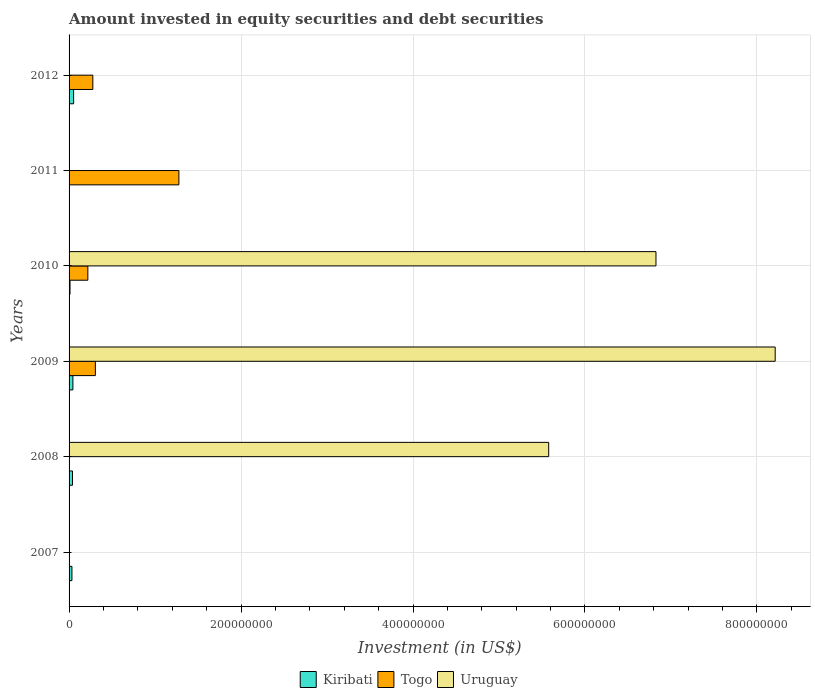Are the number of bars on each tick of the Y-axis equal?
Offer a terse response. No. How many bars are there on the 1st tick from the top?
Give a very brief answer. 2. How many bars are there on the 2nd tick from the bottom?
Keep it short and to the point. 2. What is the label of the 1st group of bars from the top?
Provide a short and direct response. 2012. In how many cases, is the number of bars for a given year not equal to the number of legend labels?
Ensure brevity in your answer.  4. What is the amount invested in equity securities and debt securities in Kiribati in 2011?
Your response must be concise. 0. Across all years, what is the maximum amount invested in equity securities and debt securities in Kiribati?
Offer a very short reply. 5.30e+06. What is the total amount invested in equity securities and debt securities in Togo in the graph?
Your response must be concise. 2.08e+08. What is the difference between the amount invested in equity securities and debt securities in Kiribati in 2008 and that in 2010?
Keep it short and to the point. 2.87e+06. What is the difference between the amount invested in equity securities and debt securities in Kiribati in 2011 and the amount invested in equity securities and debt securities in Uruguay in 2007?
Ensure brevity in your answer.  0. What is the average amount invested in equity securities and debt securities in Togo per year?
Provide a succinct answer. 3.46e+07. In the year 2009, what is the difference between the amount invested in equity securities and debt securities in Uruguay and amount invested in equity securities and debt securities in Kiribati?
Keep it short and to the point. 8.17e+08. In how many years, is the amount invested in equity securities and debt securities in Togo greater than 760000000 US$?
Offer a very short reply. 0. What is the ratio of the amount invested in equity securities and debt securities in Togo in 2009 to that in 2011?
Offer a very short reply. 0.24. What is the difference between the highest and the second highest amount invested in equity securities and debt securities in Kiribati?
Offer a terse response. 8.62e+05. What is the difference between the highest and the lowest amount invested in equity securities and debt securities in Uruguay?
Offer a very short reply. 8.21e+08. In how many years, is the amount invested in equity securities and debt securities in Togo greater than the average amount invested in equity securities and debt securities in Togo taken over all years?
Provide a short and direct response. 1. Is the sum of the amount invested in equity securities and debt securities in Kiribati in 2008 and 2010 greater than the maximum amount invested in equity securities and debt securities in Togo across all years?
Make the answer very short. No. Does the graph contain any zero values?
Provide a short and direct response. Yes. Does the graph contain grids?
Your answer should be compact. Yes. Where does the legend appear in the graph?
Your response must be concise. Bottom center. How many legend labels are there?
Provide a succinct answer. 3. What is the title of the graph?
Your response must be concise. Amount invested in equity securities and debt securities. Does "Somalia" appear as one of the legend labels in the graph?
Your response must be concise. No. What is the label or title of the X-axis?
Give a very brief answer. Investment (in US$). What is the Investment (in US$) of Kiribati in 2007?
Offer a very short reply. 3.34e+06. What is the Investment (in US$) of Togo in 2007?
Your response must be concise. 0. What is the Investment (in US$) of Uruguay in 2007?
Offer a very short reply. 0. What is the Investment (in US$) in Kiribati in 2008?
Your response must be concise. 3.97e+06. What is the Investment (in US$) in Togo in 2008?
Your answer should be compact. 0. What is the Investment (in US$) of Uruguay in 2008?
Provide a succinct answer. 5.58e+08. What is the Investment (in US$) of Kiribati in 2009?
Offer a very short reply. 4.43e+06. What is the Investment (in US$) of Togo in 2009?
Your response must be concise. 3.06e+07. What is the Investment (in US$) in Uruguay in 2009?
Ensure brevity in your answer.  8.21e+08. What is the Investment (in US$) in Kiribati in 2010?
Give a very brief answer. 1.10e+06. What is the Investment (in US$) of Togo in 2010?
Your response must be concise. 2.18e+07. What is the Investment (in US$) of Uruguay in 2010?
Ensure brevity in your answer.  6.83e+08. What is the Investment (in US$) in Togo in 2011?
Your response must be concise. 1.28e+08. What is the Investment (in US$) in Kiribati in 2012?
Your response must be concise. 5.30e+06. What is the Investment (in US$) in Togo in 2012?
Provide a short and direct response. 2.76e+07. Across all years, what is the maximum Investment (in US$) of Kiribati?
Give a very brief answer. 5.30e+06. Across all years, what is the maximum Investment (in US$) of Togo?
Provide a short and direct response. 1.28e+08. Across all years, what is the maximum Investment (in US$) in Uruguay?
Offer a terse response. 8.21e+08. Across all years, what is the minimum Investment (in US$) of Togo?
Make the answer very short. 0. Across all years, what is the minimum Investment (in US$) of Uruguay?
Offer a very short reply. 0. What is the total Investment (in US$) of Kiribati in the graph?
Keep it short and to the point. 1.81e+07. What is the total Investment (in US$) in Togo in the graph?
Your response must be concise. 2.08e+08. What is the total Investment (in US$) of Uruguay in the graph?
Offer a very short reply. 2.06e+09. What is the difference between the Investment (in US$) of Kiribati in 2007 and that in 2008?
Offer a terse response. -6.28e+05. What is the difference between the Investment (in US$) in Kiribati in 2007 and that in 2009?
Provide a succinct answer. -1.09e+06. What is the difference between the Investment (in US$) of Kiribati in 2007 and that in 2010?
Your response must be concise. 2.24e+06. What is the difference between the Investment (in US$) of Kiribati in 2007 and that in 2012?
Your answer should be very brief. -1.96e+06. What is the difference between the Investment (in US$) of Kiribati in 2008 and that in 2009?
Your answer should be compact. -4.67e+05. What is the difference between the Investment (in US$) of Uruguay in 2008 and that in 2009?
Ensure brevity in your answer.  -2.63e+08. What is the difference between the Investment (in US$) in Kiribati in 2008 and that in 2010?
Make the answer very short. 2.87e+06. What is the difference between the Investment (in US$) of Uruguay in 2008 and that in 2010?
Give a very brief answer. -1.25e+08. What is the difference between the Investment (in US$) in Kiribati in 2008 and that in 2012?
Ensure brevity in your answer.  -1.33e+06. What is the difference between the Investment (in US$) in Kiribati in 2009 and that in 2010?
Give a very brief answer. 3.34e+06. What is the difference between the Investment (in US$) in Togo in 2009 and that in 2010?
Keep it short and to the point. 8.74e+06. What is the difference between the Investment (in US$) of Uruguay in 2009 and that in 2010?
Offer a terse response. 1.39e+08. What is the difference between the Investment (in US$) in Togo in 2009 and that in 2011?
Your response must be concise. -9.71e+07. What is the difference between the Investment (in US$) in Kiribati in 2009 and that in 2012?
Ensure brevity in your answer.  -8.62e+05. What is the difference between the Investment (in US$) of Togo in 2009 and that in 2012?
Give a very brief answer. 2.93e+06. What is the difference between the Investment (in US$) in Togo in 2010 and that in 2011?
Make the answer very short. -1.06e+08. What is the difference between the Investment (in US$) in Kiribati in 2010 and that in 2012?
Provide a short and direct response. -4.20e+06. What is the difference between the Investment (in US$) of Togo in 2010 and that in 2012?
Offer a terse response. -5.81e+06. What is the difference between the Investment (in US$) in Togo in 2011 and that in 2012?
Your answer should be compact. 1.00e+08. What is the difference between the Investment (in US$) in Kiribati in 2007 and the Investment (in US$) in Uruguay in 2008?
Make the answer very short. -5.54e+08. What is the difference between the Investment (in US$) of Kiribati in 2007 and the Investment (in US$) of Togo in 2009?
Your response must be concise. -2.72e+07. What is the difference between the Investment (in US$) of Kiribati in 2007 and the Investment (in US$) of Uruguay in 2009?
Ensure brevity in your answer.  -8.18e+08. What is the difference between the Investment (in US$) of Kiribati in 2007 and the Investment (in US$) of Togo in 2010?
Provide a succinct answer. -1.85e+07. What is the difference between the Investment (in US$) in Kiribati in 2007 and the Investment (in US$) in Uruguay in 2010?
Make the answer very short. -6.79e+08. What is the difference between the Investment (in US$) in Kiribati in 2007 and the Investment (in US$) in Togo in 2011?
Offer a very short reply. -1.24e+08. What is the difference between the Investment (in US$) of Kiribati in 2007 and the Investment (in US$) of Togo in 2012?
Your answer should be compact. -2.43e+07. What is the difference between the Investment (in US$) in Kiribati in 2008 and the Investment (in US$) in Togo in 2009?
Give a very brief answer. -2.66e+07. What is the difference between the Investment (in US$) in Kiribati in 2008 and the Investment (in US$) in Uruguay in 2009?
Your answer should be compact. -8.17e+08. What is the difference between the Investment (in US$) in Kiribati in 2008 and the Investment (in US$) in Togo in 2010?
Offer a terse response. -1.79e+07. What is the difference between the Investment (in US$) of Kiribati in 2008 and the Investment (in US$) of Uruguay in 2010?
Your response must be concise. -6.79e+08. What is the difference between the Investment (in US$) in Kiribati in 2008 and the Investment (in US$) in Togo in 2011?
Your answer should be very brief. -1.24e+08. What is the difference between the Investment (in US$) in Kiribati in 2008 and the Investment (in US$) in Togo in 2012?
Your answer should be compact. -2.37e+07. What is the difference between the Investment (in US$) of Kiribati in 2009 and the Investment (in US$) of Togo in 2010?
Your answer should be compact. -1.74e+07. What is the difference between the Investment (in US$) of Kiribati in 2009 and the Investment (in US$) of Uruguay in 2010?
Your answer should be compact. -6.78e+08. What is the difference between the Investment (in US$) in Togo in 2009 and the Investment (in US$) in Uruguay in 2010?
Provide a succinct answer. -6.52e+08. What is the difference between the Investment (in US$) in Kiribati in 2009 and the Investment (in US$) in Togo in 2011?
Offer a very short reply. -1.23e+08. What is the difference between the Investment (in US$) in Kiribati in 2009 and the Investment (in US$) in Togo in 2012?
Your answer should be compact. -2.32e+07. What is the difference between the Investment (in US$) in Kiribati in 2010 and the Investment (in US$) in Togo in 2011?
Give a very brief answer. -1.27e+08. What is the difference between the Investment (in US$) in Kiribati in 2010 and the Investment (in US$) in Togo in 2012?
Your answer should be very brief. -2.65e+07. What is the average Investment (in US$) of Kiribati per year?
Your answer should be compact. 3.02e+06. What is the average Investment (in US$) of Togo per year?
Your answer should be very brief. 3.46e+07. What is the average Investment (in US$) of Uruguay per year?
Make the answer very short. 3.44e+08. In the year 2008, what is the difference between the Investment (in US$) in Kiribati and Investment (in US$) in Uruguay?
Make the answer very short. -5.54e+08. In the year 2009, what is the difference between the Investment (in US$) of Kiribati and Investment (in US$) of Togo?
Provide a succinct answer. -2.61e+07. In the year 2009, what is the difference between the Investment (in US$) in Kiribati and Investment (in US$) in Uruguay?
Offer a terse response. -8.17e+08. In the year 2009, what is the difference between the Investment (in US$) of Togo and Investment (in US$) of Uruguay?
Your answer should be compact. -7.91e+08. In the year 2010, what is the difference between the Investment (in US$) of Kiribati and Investment (in US$) of Togo?
Provide a short and direct response. -2.07e+07. In the year 2010, what is the difference between the Investment (in US$) in Kiribati and Investment (in US$) in Uruguay?
Your answer should be very brief. -6.81e+08. In the year 2010, what is the difference between the Investment (in US$) in Togo and Investment (in US$) in Uruguay?
Ensure brevity in your answer.  -6.61e+08. In the year 2012, what is the difference between the Investment (in US$) of Kiribati and Investment (in US$) of Togo?
Give a very brief answer. -2.23e+07. What is the ratio of the Investment (in US$) in Kiribati in 2007 to that in 2008?
Offer a very short reply. 0.84. What is the ratio of the Investment (in US$) in Kiribati in 2007 to that in 2009?
Your answer should be very brief. 0.75. What is the ratio of the Investment (in US$) of Kiribati in 2007 to that in 2010?
Ensure brevity in your answer.  3.05. What is the ratio of the Investment (in US$) of Kiribati in 2007 to that in 2012?
Give a very brief answer. 0.63. What is the ratio of the Investment (in US$) in Kiribati in 2008 to that in 2009?
Offer a terse response. 0.89. What is the ratio of the Investment (in US$) of Uruguay in 2008 to that in 2009?
Your answer should be very brief. 0.68. What is the ratio of the Investment (in US$) of Kiribati in 2008 to that in 2010?
Give a very brief answer. 3.62. What is the ratio of the Investment (in US$) in Uruguay in 2008 to that in 2010?
Provide a short and direct response. 0.82. What is the ratio of the Investment (in US$) in Kiribati in 2008 to that in 2012?
Make the answer very short. 0.75. What is the ratio of the Investment (in US$) of Kiribati in 2009 to that in 2010?
Make the answer very short. 4.05. What is the ratio of the Investment (in US$) in Togo in 2009 to that in 2010?
Offer a terse response. 1.4. What is the ratio of the Investment (in US$) of Uruguay in 2009 to that in 2010?
Your answer should be compact. 1.2. What is the ratio of the Investment (in US$) in Togo in 2009 to that in 2011?
Offer a very short reply. 0.24. What is the ratio of the Investment (in US$) in Kiribati in 2009 to that in 2012?
Your answer should be compact. 0.84. What is the ratio of the Investment (in US$) of Togo in 2009 to that in 2012?
Offer a very short reply. 1.11. What is the ratio of the Investment (in US$) in Togo in 2010 to that in 2011?
Keep it short and to the point. 0.17. What is the ratio of the Investment (in US$) of Kiribati in 2010 to that in 2012?
Your answer should be compact. 0.21. What is the ratio of the Investment (in US$) in Togo in 2010 to that in 2012?
Your answer should be compact. 0.79. What is the ratio of the Investment (in US$) in Togo in 2011 to that in 2012?
Keep it short and to the point. 4.62. What is the difference between the highest and the second highest Investment (in US$) of Kiribati?
Your response must be concise. 8.62e+05. What is the difference between the highest and the second highest Investment (in US$) in Togo?
Ensure brevity in your answer.  9.71e+07. What is the difference between the highest and the second highest Investment (in US$) of Uruguay?
Provide a short and direct response. 1.39e+08. What is the difference between the highest and the lowest Investment (in US$) of Kiribati?
Your answer should be very brief. 5.30e+06. What is the difference between the highest and the lowest Investment (in US$) of Togo?
Your answer should be very brief. 1.28e+08. What is the difference between the highest and the lowest Investment (in US$) in Uruguay?
Make the answer very short. 8.21e+08. 